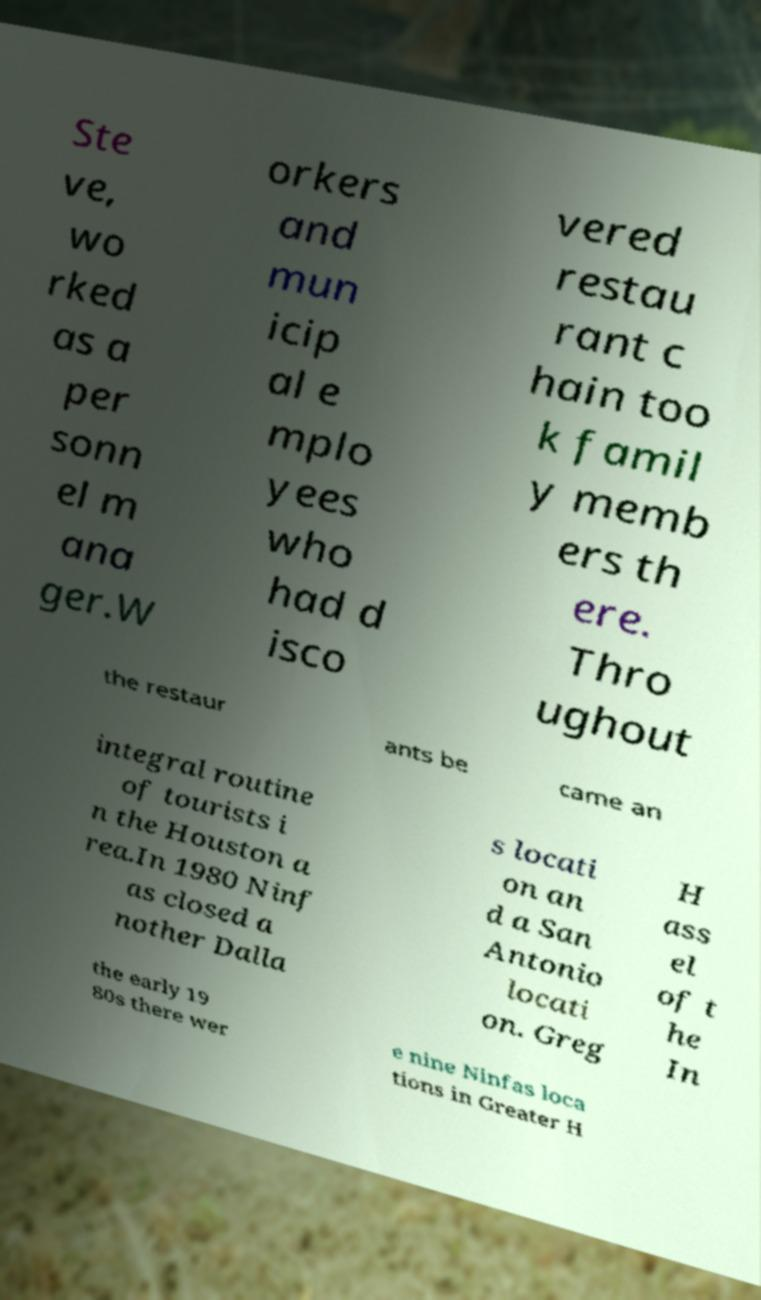Please read and relay the text visible in this image. What does it say? Ste ve, wo rked as a per sonn el m ana ger.W orkers and mun icip al e mplo yees who had d isco vered restau rant c hain too k famil y memb ers th ere. Thro ughout the restaur ants be came an integral routine of tourists i n the Houston a rea.In 1980 Ninf as closed a nother Dalla s locati on an d a San Antonio locati on. Greg H ass el of t he In the early 19 80s there wer e nine Ninfas loca tions in Greater H 